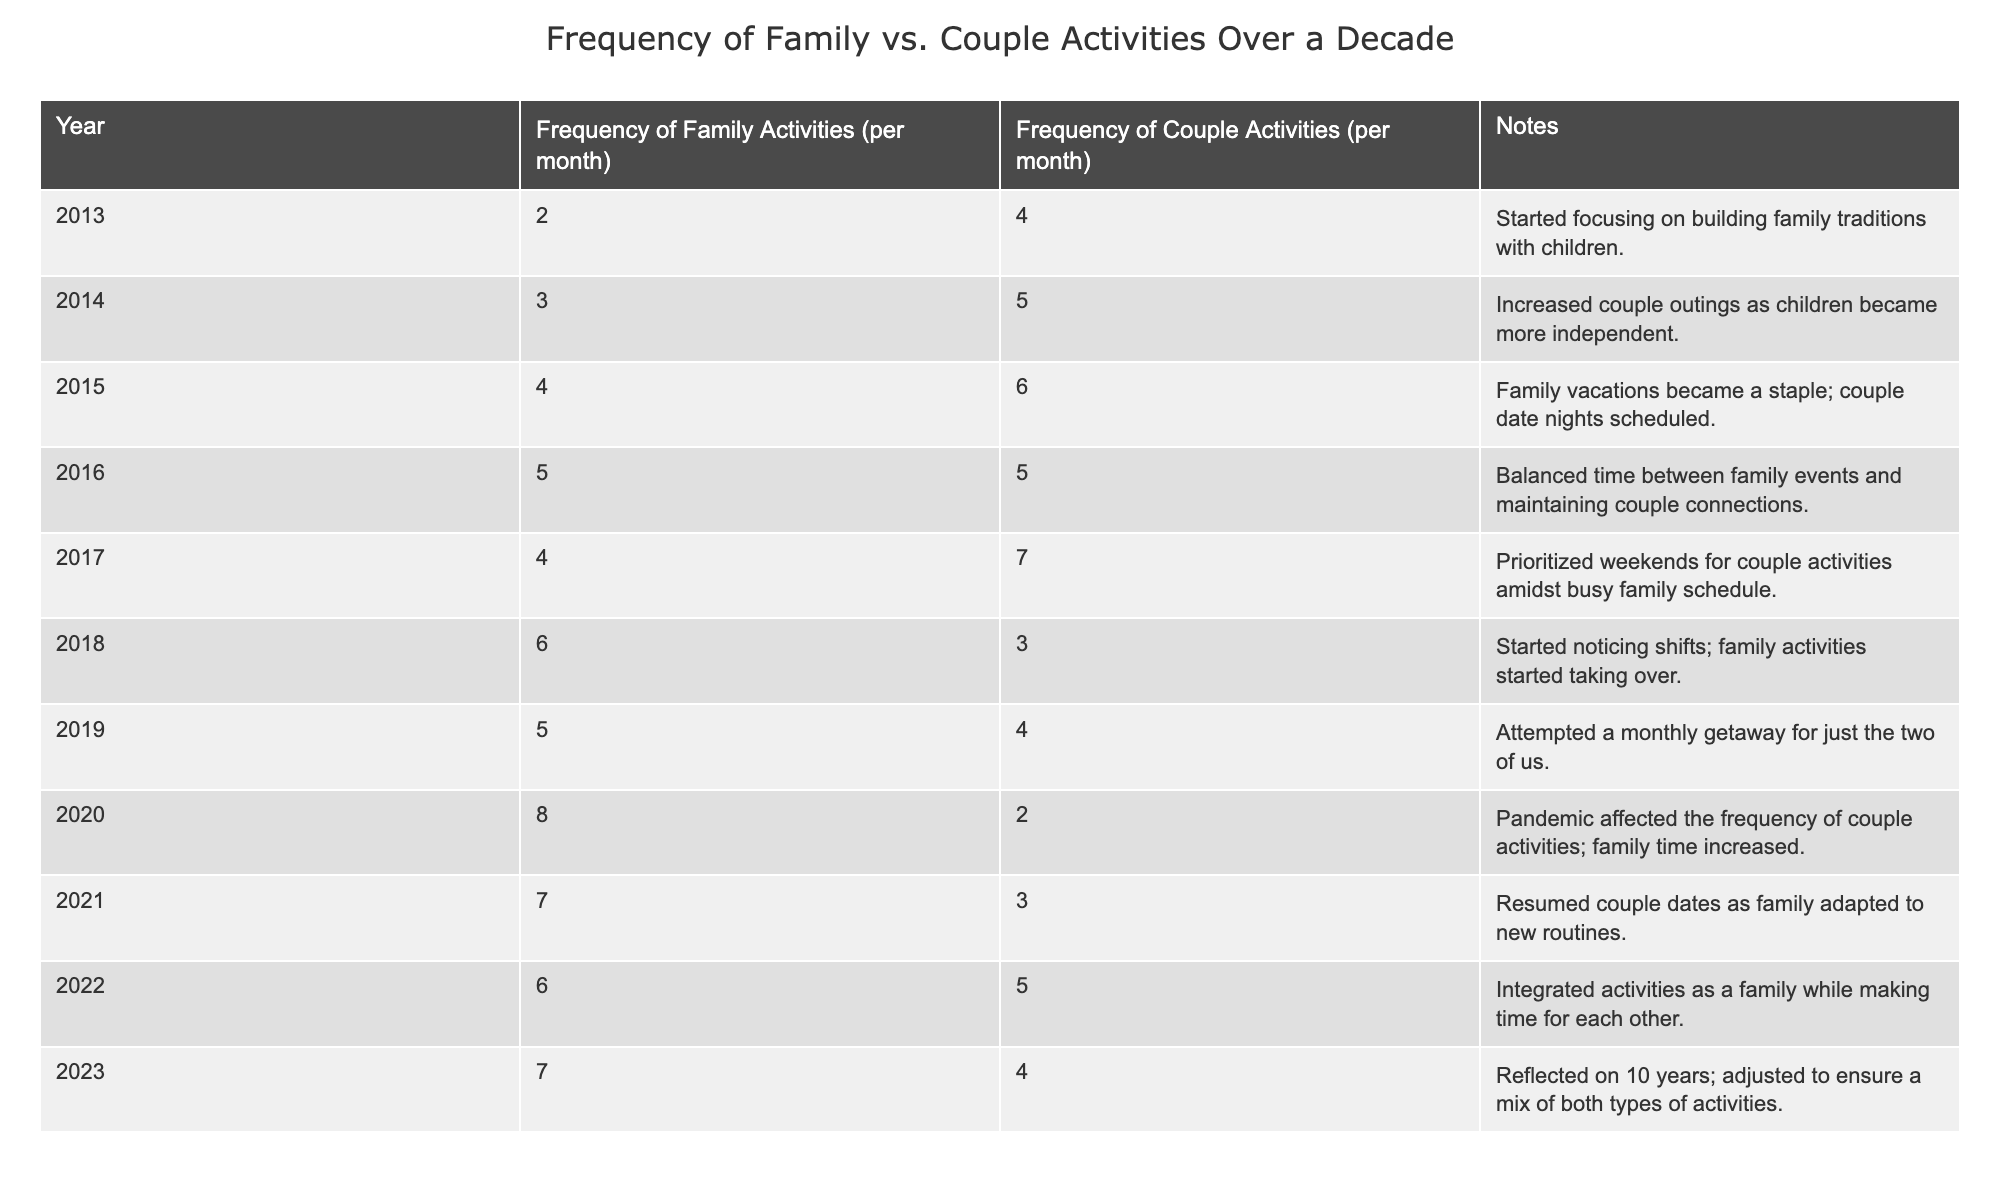What was the frequency of family activities in 2015? In the year 2015, the table shows that the frequency of family activities was listed as 4 per month.
Answer: 4 How many couple activities were recorded in 2020? According to the table, in 2020 the frequency of couple activities was recorded as 2 per month.
Answer: 2 What was the average frequency of couple activities over the decade? To find the average, we sum the couple activity frequencies for all years: (4 + 5 + 6 + 5 + 7 + 3 + 4 + 2 + 3 + 5 + 4) = 54. There are 11 data points, so the average is 54/11 = 4.91 (rounded to two decimal places).
Answer: 4.91 Was there a year when the frequency of couple activities was the same as family activities? The table shows that in 2016, the frequency of couple activities (5) was the same as family activities (5), so this is true.
Answer: Yes What is the trend in family activities from 2013 to 2023? Observing the table, we see that family activities increased from 2 per month in 2013 to 7 per month in 2023, indicating a steady upward trend.
Answer: Upward trend How did couple activities change from 2017 to 2022? In 2017, couple activities were at 7 per month, which decreased to 5 per month in 2022. This shows a decline over that period.
Answer: Decline What was the maximum frequency of family activities recorded during the decade? The highest frequency of family activities during the decade is noted in 2020, where it reached 8 per month.
Answer: 8 Which year had the lowest frequency of couple activities? The lowest frequency of couple activities occurred in 2020, where it was recorded at 2 per month.
Answer: 2020 Did the couple activities reach above their 2013 frequency after 2017? The frequency of couple activities in 2018 (3), 2019 (4), and 2021 (3) was below the 2013 frequency of 4 per month until reaching 5 in 2022, so this is a cumulative change. Therefore, starting from 2018, couple activities were primarily below 4 until 2022.
Answer: No What are the differences in family and couple activities in 2023? In 2023, family activities were 7 per month and couple activities were 4 per month. The difference is 7 - 4 = 3. Therefore, family activities exceeded couple activities by 3 per month in 2023.
Answer: 3 